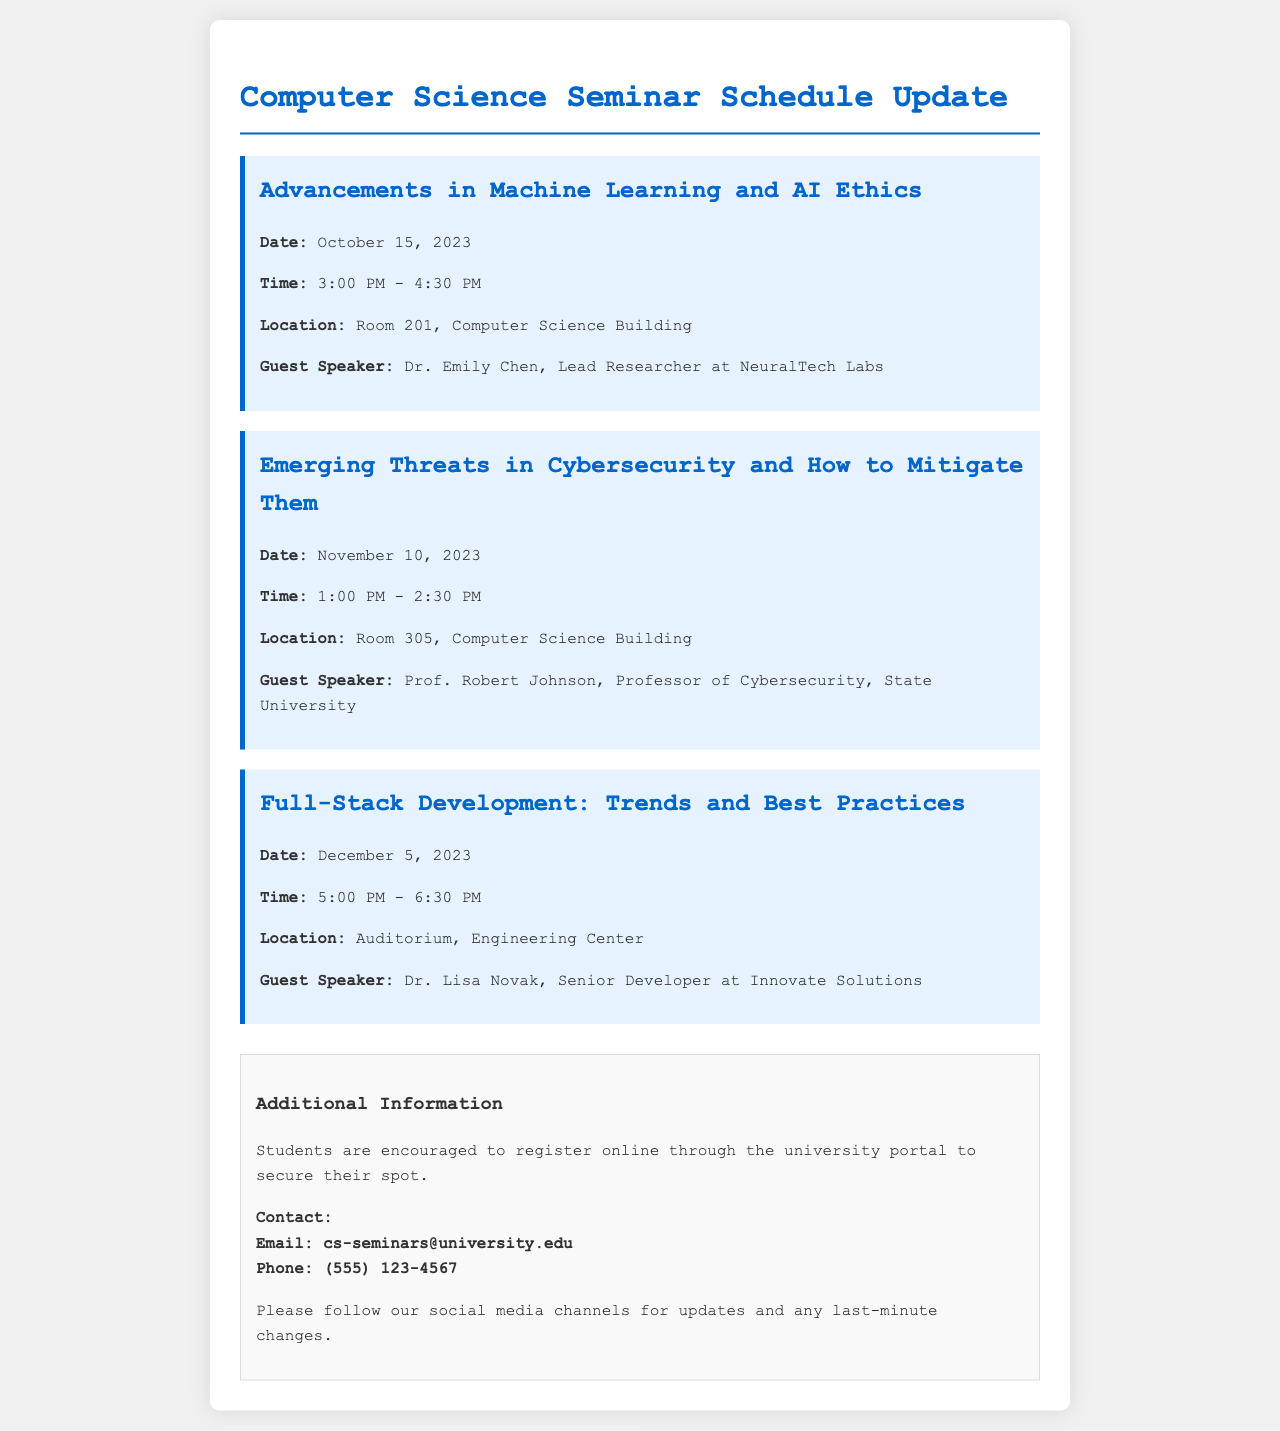What is the date of the first seminar? The first seminar is on October 15, 2023.
Answer: October 15, 2023 Who is the guest speaker for the seminar on Emerging Threats in Cybersecurity? The guest speaker for this seminar is Prof. Robert Johnson.
Answer: Prof. Robert Johnson What time does the Full-Stack Development seminar start? The seminar starts at 5:00 PM.
Answer: 5:00 PM Which room is the seminar on Advancements in Machine Learning held? This seminar is held in Room 201, Computer Science Building.
Answer: Room 201, Computer Science Building What is the main topic of the second seminar? The topic is Emerging Threats in Cybersecurity and How to Mitigate Them.
Answer: Emerging Threats in Cybersecurity and How to Mitigate Them How long is the seminar on Full-Stack Development? The seminar duration is 1.5 hours, from 5:00 PM to 6:30 PM.
Answer: 1.5 hours When is the last seminar scheduled? The last seminar is scheduled for December 5, 2023.
Answer: December 5, 2023 What should students do to secure their spot at the seminars? Students should register online through the university portal.
Answer: Register online What is the contact email for seminar inquiries? The contact email provided for inquiries is cs-seminars@university.edu.
Answer: cs-seminars@university.edu What color is the background of the document? The background color of the document is light gray (#f0f0f0).
Answer: Light gray 